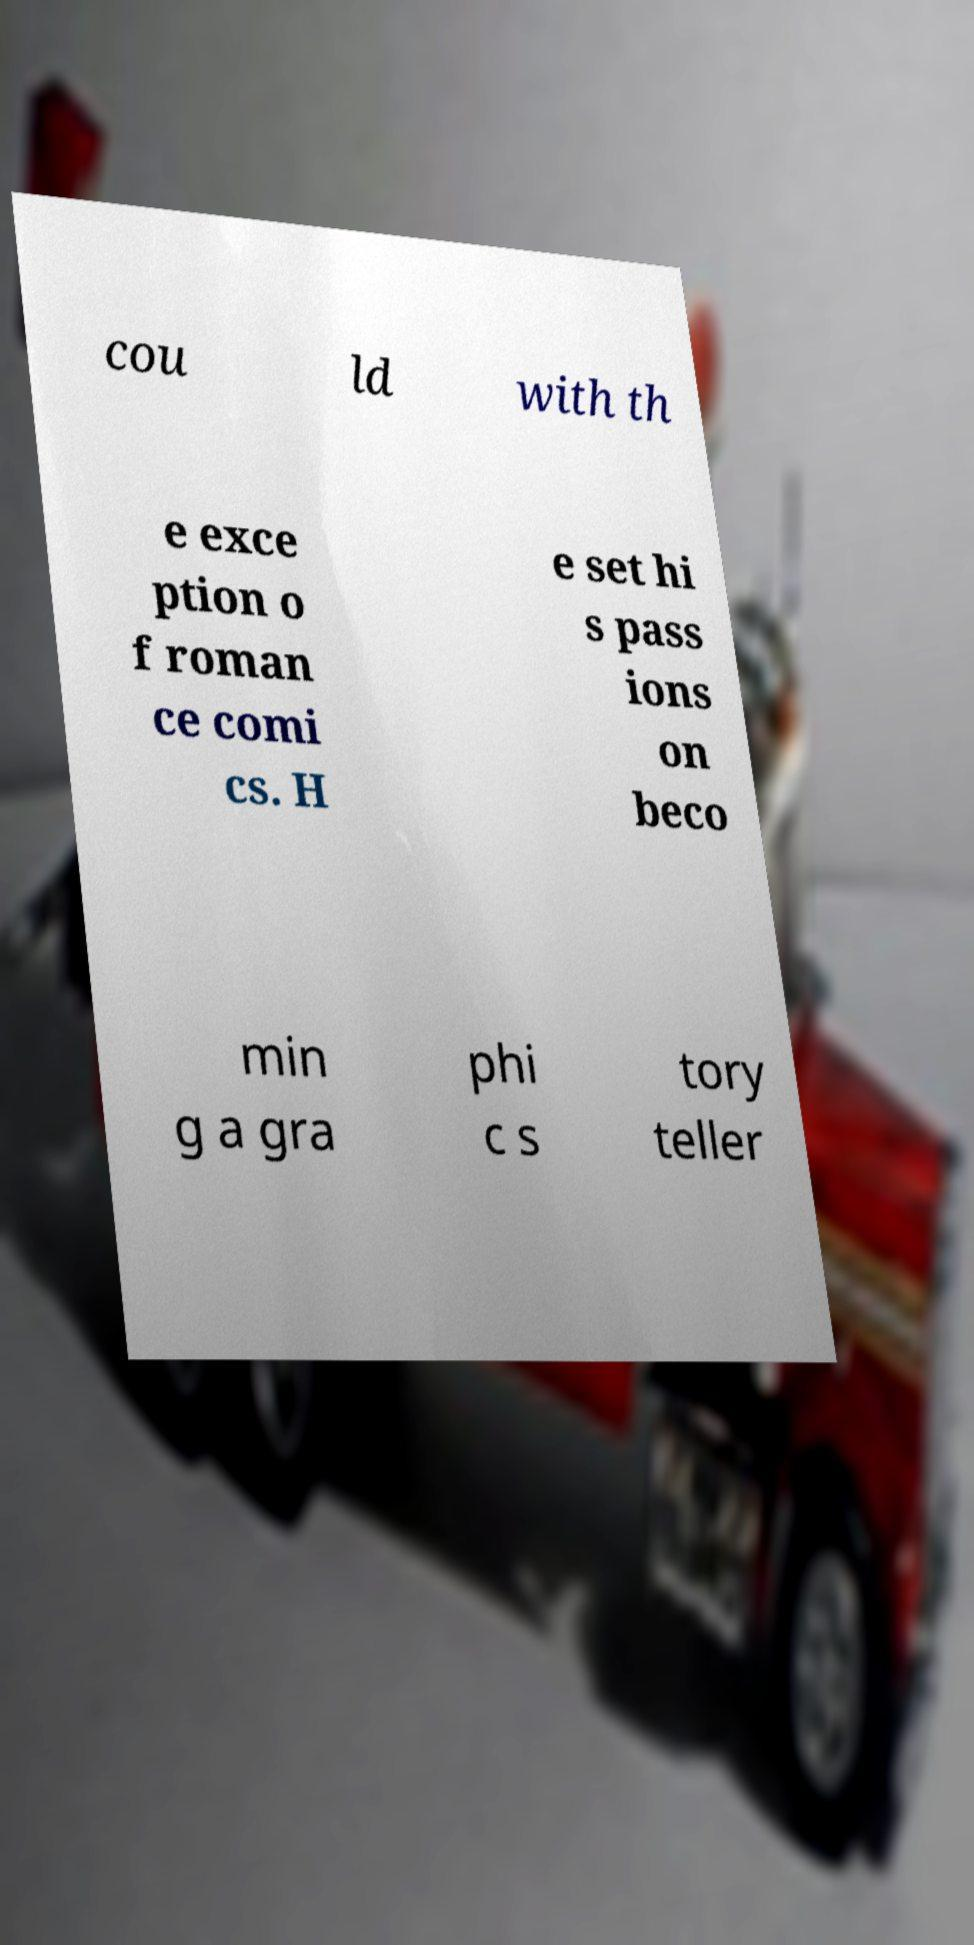Please identify and transcribe the text found in this image. cou ld with th e exce ption o f roman ce comi cs. H e set hi s pass ions on beco min g a gra phi c s tory teller 